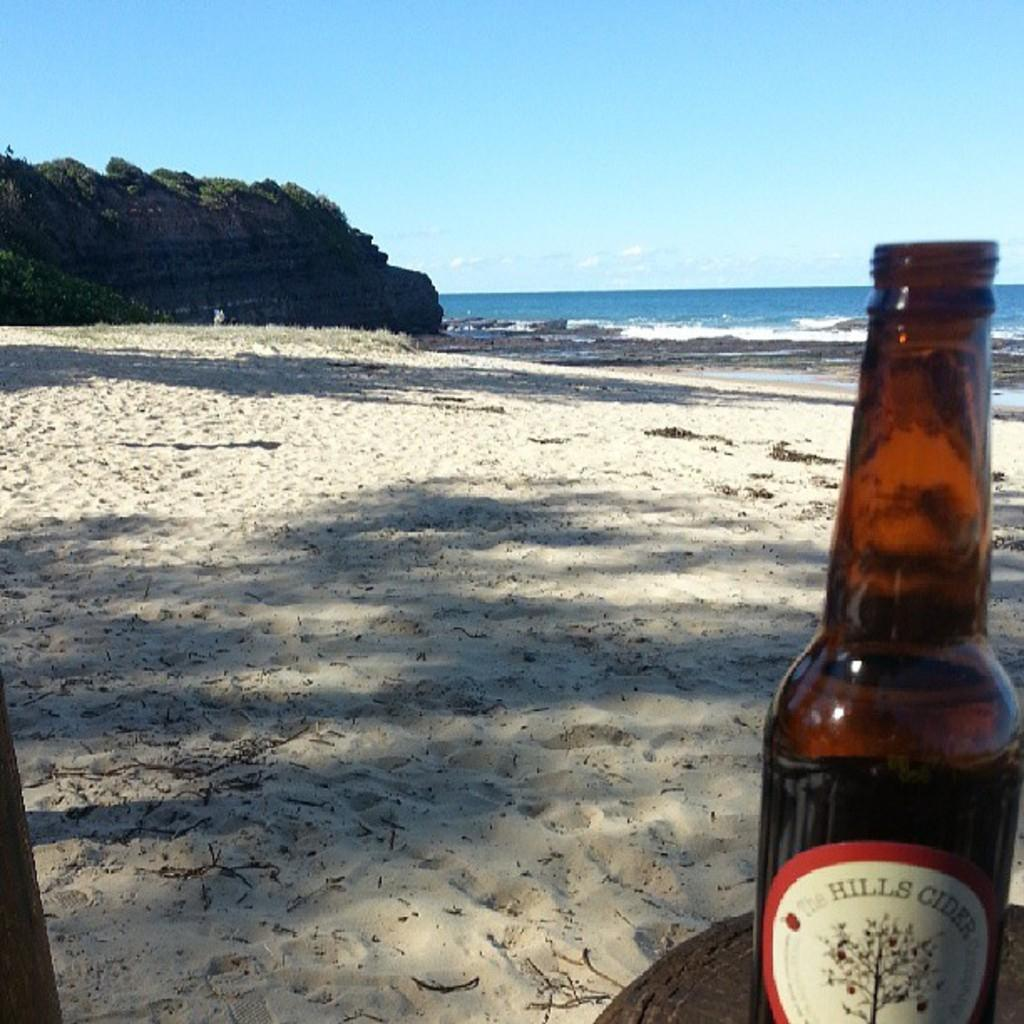Provide a one-sentence caption for the provided image. A Hills Cider bottle is in the sand along the beach. 